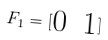Convert formula to latex. <formula><loc_0><loc_0><loc_500><loc_500>F _ { 1 } = [ \begin{matrix} 0 & 1 \end{matrix} ]</formula> 